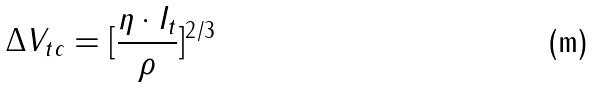<formula> <loc_0><loc_0><loc_500><loc_500>\Delta V _ { t c } = [ \frac { \eta \cdot I _ { t } } { \rho } ] ^ { 2 / 3 }</formula> 